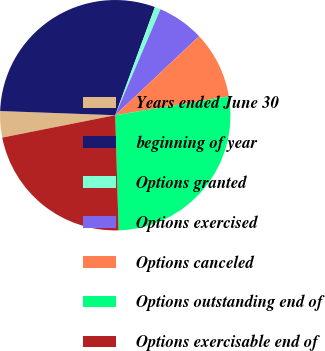Convert chart. <chart><loc_0><loc_0><loc_500><loc_500><pie_chart><fcel>Years ended June 30<fcel>beginning of year<fcel>Options granted<fcel>Options exercised<fcel>Options canceled<fcel>Options outstanding end of<fcel>Options exercisable end of<nl><fcel>3.69%<fcel>30.01%<fcel>0.83%<fcel>6.55%<fcel>9.41%<fcel>27.15%<fcel>22.35%<nl></chart> 